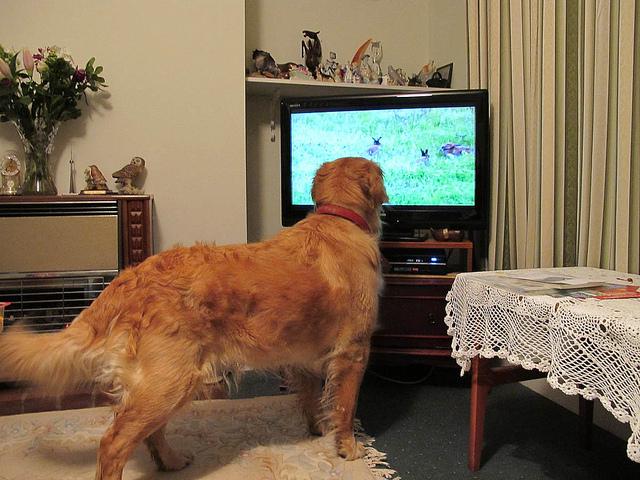What animals are in the picture?
Give a very brief answer. Dog. Is the dog going for a walk on the beach?
Short answer required. No. What breed of dog is this?
Quick response, please. Golden retriever. Is the dog watching TV?
Give a very brief answer. Yes. Is the dog facing the camera?
Keep it brief. No. 